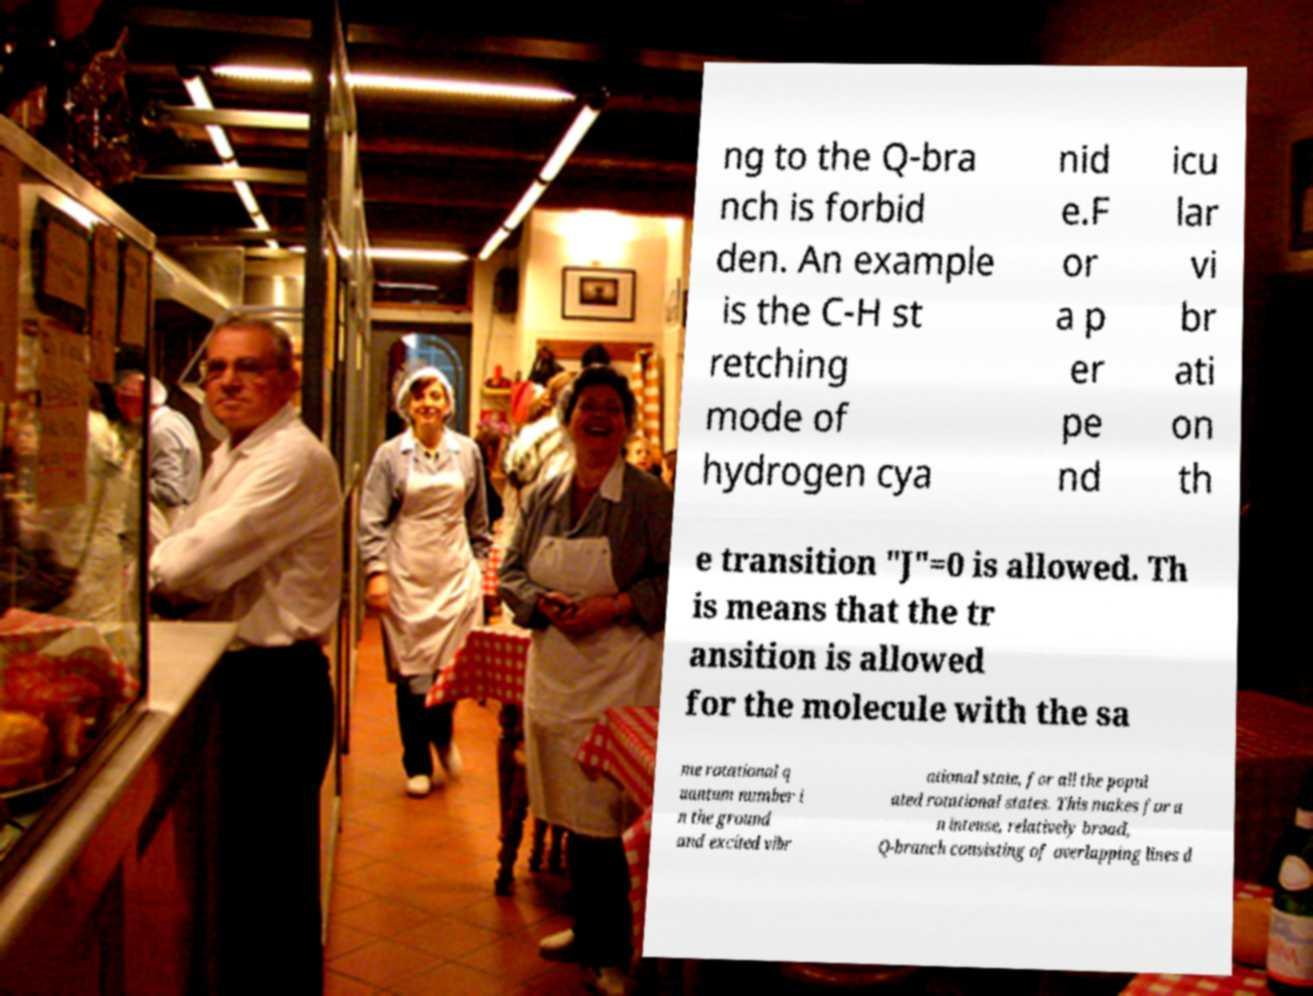What messages or text are displayed in this image? I need them in a readable, typed format. ng to the Q-bra nch is forbid den. An example is the C-H st retching mode of hydrogen cya nid e.F or a p er pe nd icu lar vi br ati on th e transition "J"=0 is allowed. Th is means that the tr ansition is allowed for the molecule with the sa me rotational q uantum number i n the ground and excited vibr ational state, for all the popul ated rotational states. This makes for a n intense, relatively broad, Q-branch consisting of overlapping lines d 